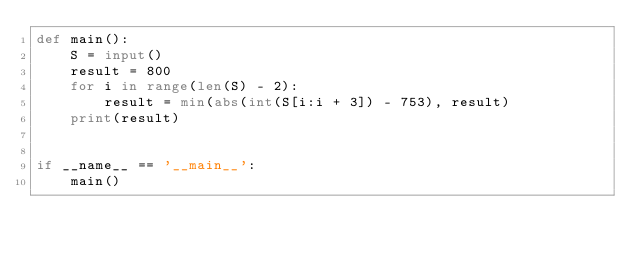Convert code to text. <code><loc_0><loc_0><loc_500><loc_500><_Python_>def main():
    S = input()
    result = 800
    for i in range(len(S) - 2):
        result = min(abs(int(S[i:i + 3]) - 753), result)
    print(result)


if __name__ == '__main__':
    main()</code> 